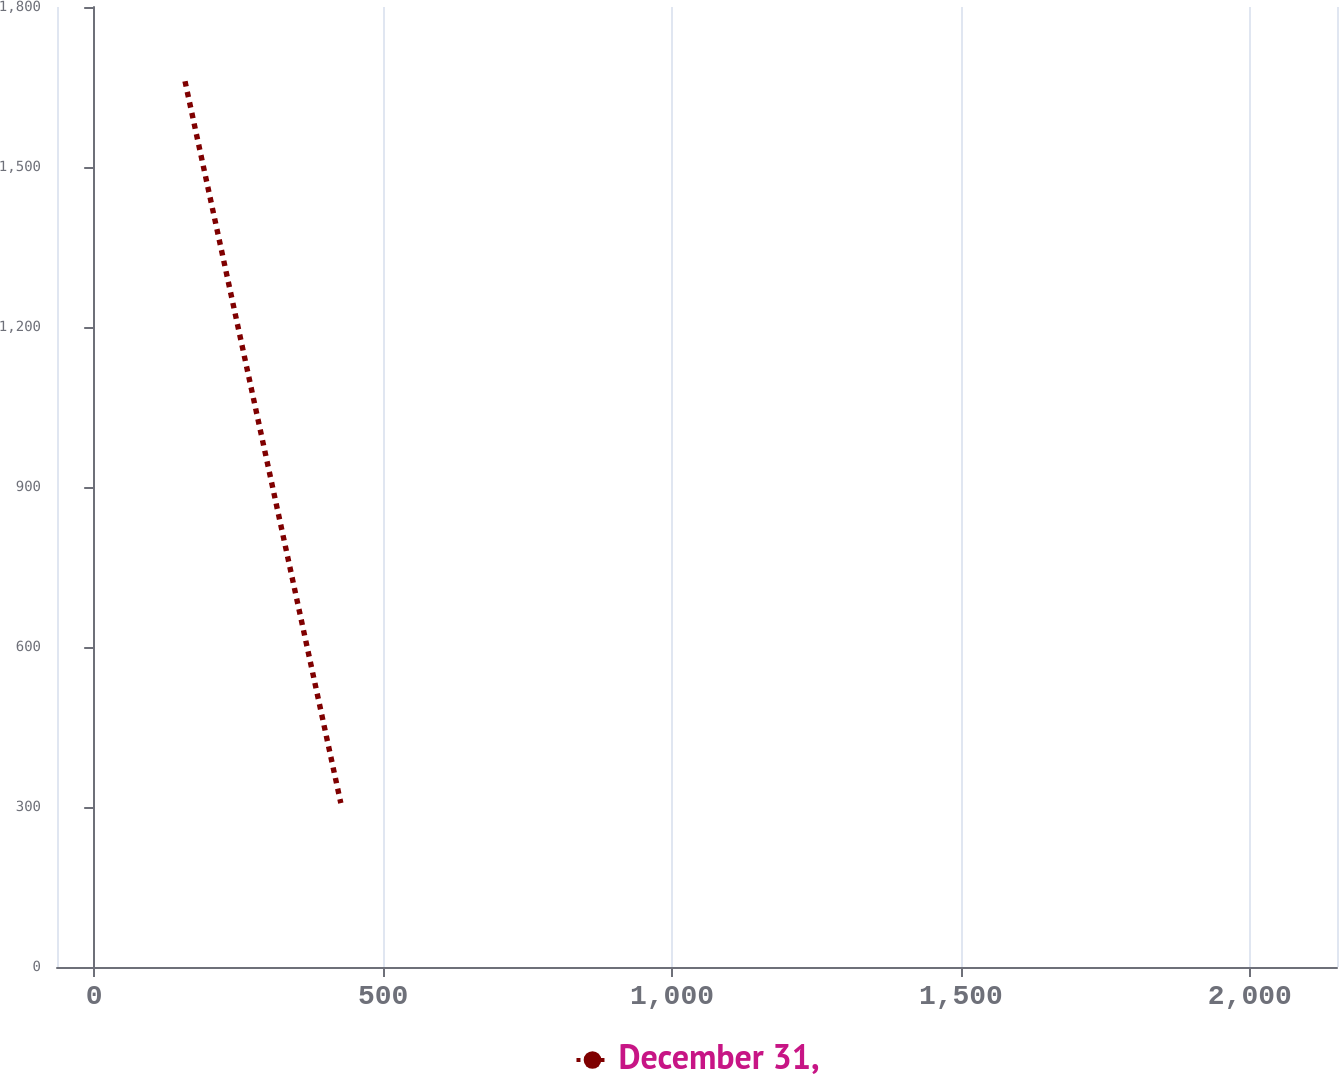<chart> <loc_0><loc_0><loc_500><loc_500><line_chart><ecel><fcel>December 31,<nl><fcel>157.16<fcel>1660.74<nl><fcel>426.83<fcel>307.24<nl><fcel>2372.39<fcel>138.11<nl></chart> 